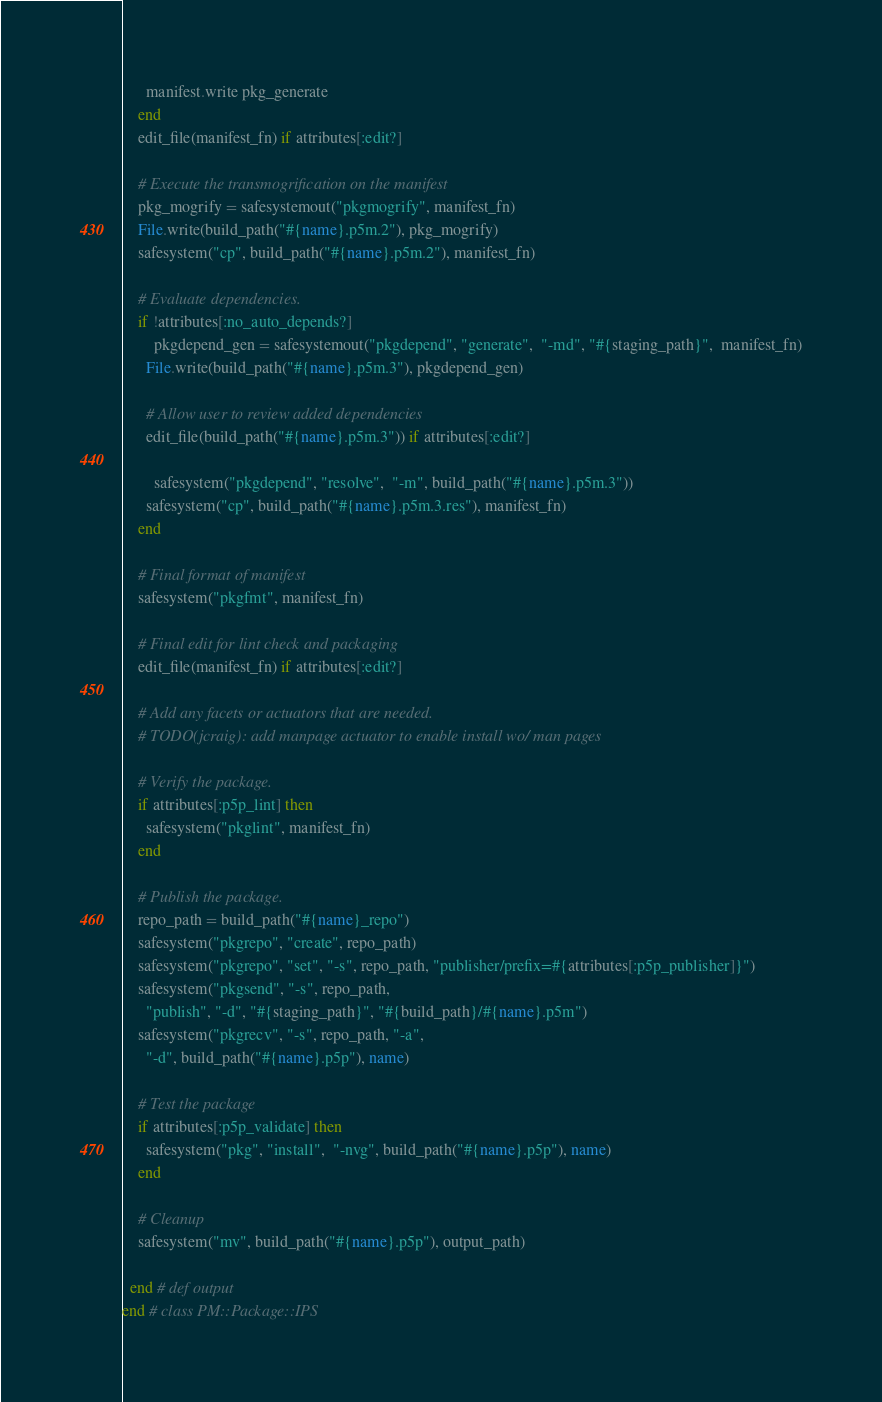Convert code to text. <code><loc_0><loc_0><loc_500><loc_500><_Ruby_>      manifest.write pkg_generate
    end
    edit_file(manifest_fn) if attributes[:edit?]

    # Execute the transmogrification on the manifest
    pkg_mogrify = safesystemout("pkgmogrify", manifest_fn)
    File.write(build_path("#{name}.p5m.2"), pkg_mogrify)
    safesystem("cp", build_path("#{name}.p5m.2"), manifest_fn)

    # Evaluate dependencies.
    if !attributes[:no_auto_depends?]
	    pkgdepend_gen = safesystemout("pkgdepend", "generate",  "-md", "#{staging_path}",  manifest_fn)
      File.write(build_path("#{name}.p5m.3"), pkgdepend_gen)

      # Allow user to review added dependencies
      edit_file(build_path("#{name}.p5m.3")) if attributes[:edit?]

	    safesystem("pkgdepend", "resolve",  "-m", build_path("#{name}.p5m.3"))
      safesystem("cp", build_path("#{name}.p5m.3.res"), manifest_fn)
    end

    # Final format of manifest
    safesystem("pkgfmt", manifest_fn)

    # Final edit for lint check and packaging
    edit_file(manifest_fn) if attributes[:edit?]

    # Add any facets or actuators that are needed.
    # TODO(jcraig): add manpage actuator to enable install wo/ man pages

    # Verify the package.
    if attributes[:p5p_lint] then
      safesystem("pkglint", manifest_fn)
    end

    # Publish the package.
    repo_path = build_path("#{name}_repo")
    safesystem("pkgrepo", "create", repo_path)
    safesystem("pkgrepo", "set", "-s", repo_path, "publisher/prefix=#{attributes[:p5p_publisher]}")
    safesystem("pkgsend", "-s", repo_path,
      "publish", "-d", "#{staging_path}", "#{build_path}/#{name}.p5m")
    safesystem("pkgrecv", "-s", repo_path, "-a",
      "-d", build_path("#{name}.p5p"), name)

    # Test the package
    if attributes[:p5p_validate] then
      safesystem("pkg", "install",  "-nvg", build_path("#{name}.p5p"), name)
    end

    # Cleanup
    safesystem("mv", build_path("#{name}.p5p"), output_path)

  end # def output
end # class PM::Package::IPS
</code> 